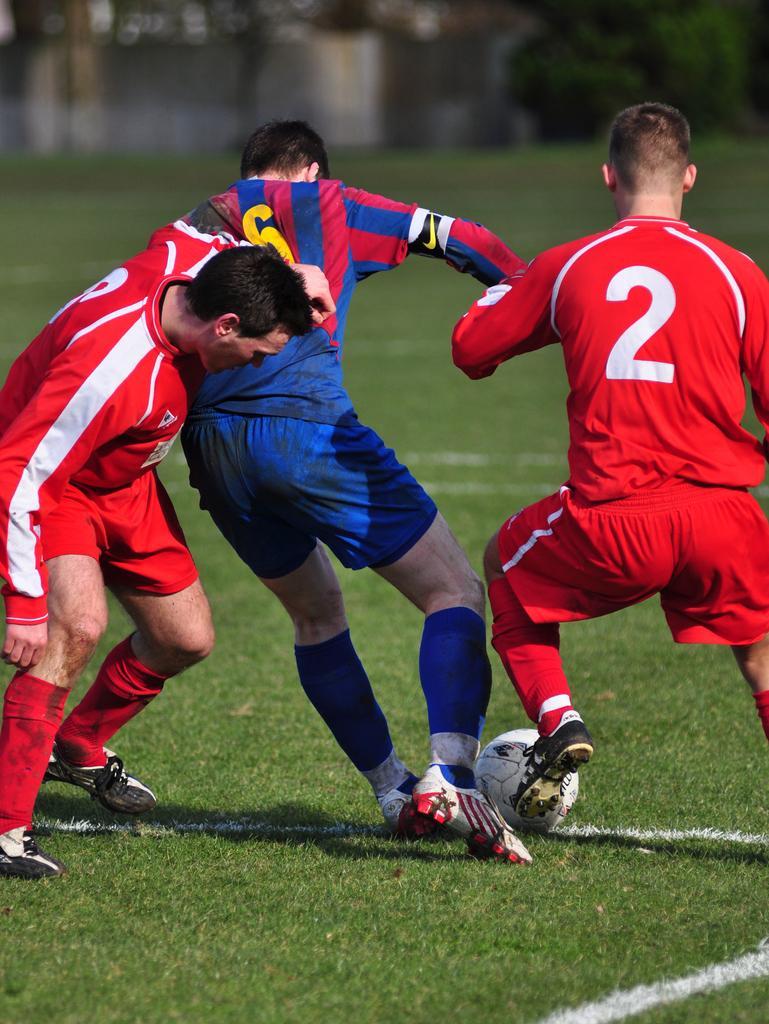How would you summarize this image in a sentence or two? In this image i can see 2 persons in red jersey and a person in blue jersey are playing a football, and i can see a football over here. In the background i can see the ground, the wall and few trees. 